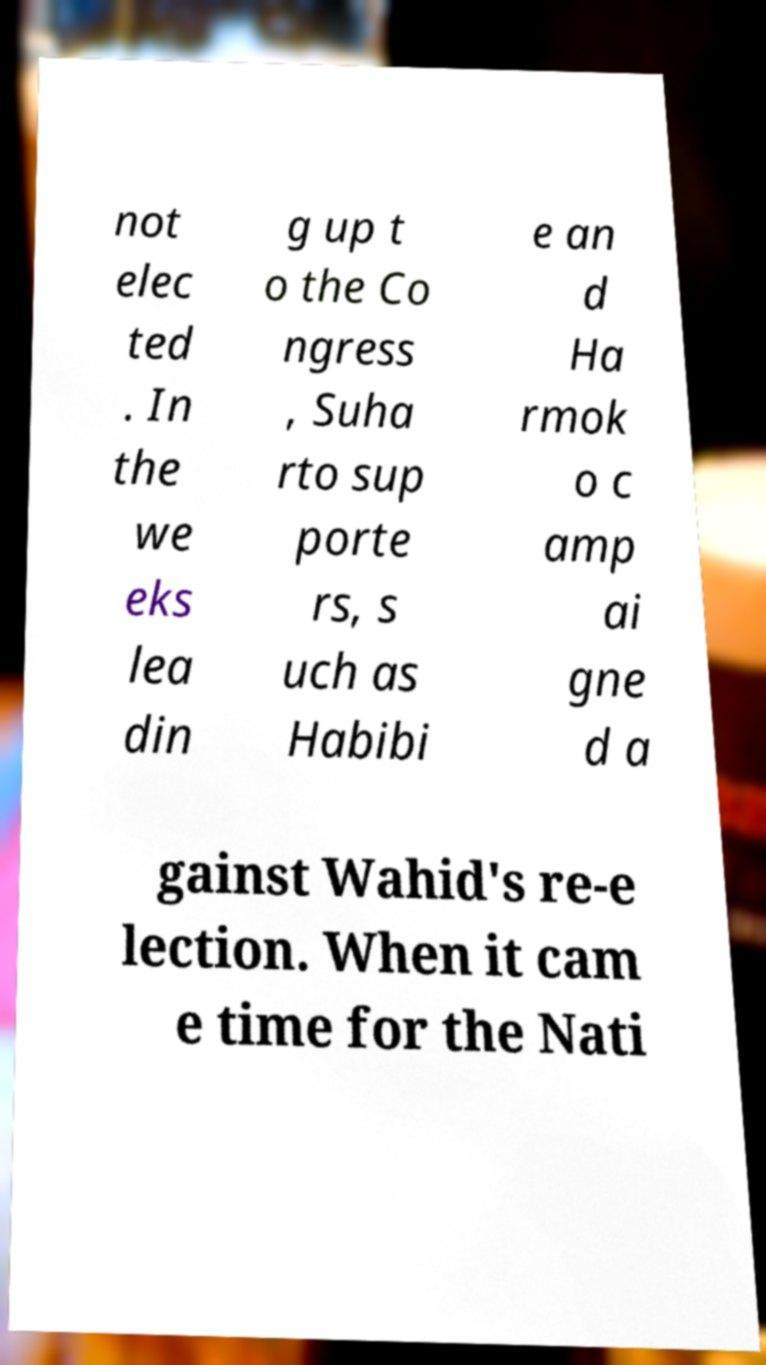Could you assist in decoding the text presented in this image and type it out clearly? not elec ted . In the we eks lea din g up t o the Co ngress , Suha rto sup porte rs, s uch as Habibi e an d Ha rmok o c amp ai gne d a gainst Wahid's re-e lection. When it cam e time for the Nati 